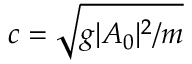Convert formula to latex. <formula><loc_0><loc_0><loc_500><loc_500>c = \sqrt { g | A _ { 0 } | ^ { 2 } / m }</formula> 